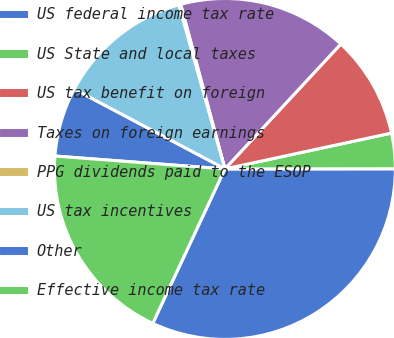Convert chart to OTSL. <chart><loc_0><loc_0><loc_500><loc_500><pie_chart><fcel>US federal income tax rate<fcel>US State and local taxes<fcel>US tax benefit on foreign<fcel>Taxes on foreign earnings<fcel>PPG dividends paid to the ESOP<fcel>US tax incentives<fcel>Other<fcel>Effective income tax rate<nl><fcel>31.97%<fcel>3.36%<fcel>9.72%<fcel>16.08%<fcel>0.18%<fcel>12.9%<fcel>6.54%<fcel>19.25%<nl></chart> 